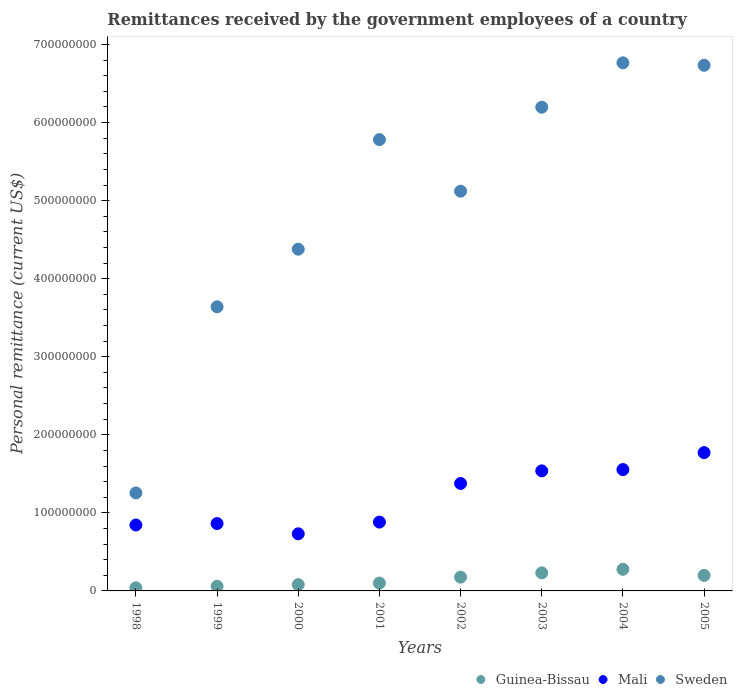What is the remittances received by the government employees in Sweden in 2004?
Offer a terse response. 6.77e+08. Across all years, what is the maximum remittances received by the government employees in Guinea-Bissau?
Your answer should be very brief. 2.77e+07. Across all years, what is the minimum remittances received by the government employees in Mali?
Keep it short and to the point. 7.32e+07. In which year was the remittances received by the government employees in Mali maximum?
Ensure brevity in your answer.  2005. What is the total remittances received by the government employees in Guinea-Bissau in the graph?
Your response must be concise. 1.16e+08. What is the difference between the remittances received by the government employees in Sweden in 1998 and that in 2005?
Your answer should be compact. -5.48e+08. What is the difference between the remittances received by the government employees in Guinea-Bissau in 2001 and the remittances received by the government employees in Mali in 2005?
Provide a short and direct response. -1.67e+08. What is the average remittances received by the government employees in Guinea-Bissau per year?
Make the answer very short. 1.46e+07. In the year 2002, what is the difference between the remittances received by the government employees in Mali and remittances received by the government employees in Sweden?
Provide a short and direct response. -3.74e+08. What is the ratio of the remittances received by the government employees in Mali in 2002 to that in 2003?
Provide a succinct answer. 0.9. Is the remittances received by the government employees in Mali in 1998 less than that in 2005?
Offer a terse response. Yes. Is the difference between the remittances received by the government employees in Mali in 1999 and 2002 greater than the difference between the remittances received by the government employees in Sweden in 1999 and 2002?
Offer a very short reply. Yes. What is the difference between the highest and the second highest remittances received by the government employees in Guinea-Bissau?
Offer a terse response. 4.57e+06. What is the difference between the highest and the lowest remittances received by the government employees in Guinea-Bissau?
Provide a short and direct response. 2.37e+07. In how many years, is the remittances received by the government employees in Sweden greater than the average remittances received by the government employees in Sweden taken over all years?
Your response must be concise. 5. Is it the case that in every year, the sum of the remittances received by the government employees in Mali and remittances received by the government employees in Guinea-Bissau  is greater than the remittances received by the government employees in Sweden?
Make the answer very short. No. Is the remittances received by the government employees in Sweden strictly less than the remittances received by the government employees in Guinea-Bissau over the years?
Give a very brief answer. No. What is the difference between two consecutive major ticks on the Y-axis?
Give a very brief answer. 1.00e+08. Are the values on the major ticks of Y-axis written in scientific E-notation?
Your answer should be very brief. No. Does the graph contain grids?
Your response must be concise. No. How many legend labels are there?
Your response must be concise. 3. How are the legend labels stacked?
Offer a terse response. Horizontal. What is the title of the graph?
Provide a short and direct response. Remittances received by the government employees of a country. What is the label or title of the X-axis?
Give a very brief answer. Years. What is the label or title of the Y-axis?
Provide a short and direct response. Personal remittance (current US$). What is the Personal remittance (current US$) in Guinea-Bissau in 1998?
Provide a succinct answer. 4.01e+06. What is the Personal remittance (current US$) of Mali in 1998?
Your response must be concise. 8.45e+07. What is the Personal remittance (current US$) of Sweden in 1998?
Your answer should be compact. 1.26e+08. What is the Personal remittance (current US$) of Guinea-Bissau in 1999?
Make the answer very short. 6.01e+06. What is the Personal remittance (current US$) in Mali in 1999?
Ensure brevity in your answer.  8.63e+07. What is the Personal remittance (current US$) in Sweden in 1999?
Provide a short and direct response. 3.64e+08. What is the Personal remittance (current US$) of Guinea-Bissau in 2000?
Your answer should be very brief. 8.02e+06. What is the Personal remittance (current US$) in Mali in 2000?
Give a very brief answer. 7.32e+07. What is the Personal remittance (current US$) in Sweden in 2000?
Your answer should be compact. 4.38e+08. What is the Personal remittance (current US$) in Guinea-Bissau in 2001?
Your answer should be compact. 1.00e+07. What is the Personal remittance (current US$) of Mali in 2001?
Keep it short and to the point. 8.82e+07. What is the Personal remittance (current US$) of Sweden in 2001?
Offer a very short reply. 5.78e+08. What is the Personal remittance (current US$) in Guinea-Bissau in 2002?
Offer a very short reply. 1.76e+07. What is the Personal remittance (current US$) in Mali in 2002?
Keep it short and to the point. 1.38e+08. What is the Personal remittance (current US$) in Sweden in 2002?
Ensure brevity in your answer.  5.12e+08. What is the Personal remittance (current US$) in Guinea-Bissau in 2003?
Your answer should be very brief. 2.31e+07. What is the Personal remittance (current US$) in Mali in 2003?
Ensure brevity in your answer.  1.54e+08. What is the Personal remittance (current US$) of Sweden in 2003?
Offer a very short reply. 6.20e+08. What is the Personal remittance (current US$) of Guinea-Bissau in 2004?
Ensure brevity in your answer.  2.77e+07. What is the Personal remittance (current US$) of Mali in 2004?
Make the answer very short. 1.55e+08. What is the Personal remittance (current US$) of Sweden in 2004?
Provide a succinct answer. 6.77e+08. What is the Personal remittance (current US$) in Guinea-Bissau in 2005?
Keep it short and to the point. 1.99e+07. What is the Personal remittance (current US$) in Mali in 2005?
Ensure brevity in your answer.  1.77e+08. What is the Personal remittance (current US$) in Sweden in 2005?
Keep it short and to the point. 6.73e+08. Across all years, what is the maximum Personal remittance (current US$) in Guinea-Bissau?
Ensure brevity in your answer.  2.77e+07. Across all years, what is the maximum Personal remittance (current US$) in Mali?
Make the answer very short. 1.77e+08. Across all years, what is the maximum Personal remittance (current US$) of Sweden?
Your answer should be compact. 6.77e+08. Across all years, what is the minimum Personal remittance (current US$) in Guinea-Bissau?
Your answer should be compact. 4.01e+06. Across all years, what is the minimum Personal remittance (current US$) of Mali?
Provide a short and direct response. 7.32e+07. Across all years, what is the minimum Personal remittance (current US$) of Sweden?
Your response must be concise. 1.26e+08. What is the total Personal remittance (current US$) of Guinea-Bissau in the graph?
Give a very brief answer. 1.16e+08. What is the total Personal remittance (current US$) of Mali in the graph?
Offer a terse response. 9.56e+08. What is the total Personal remittance (current US$) of Sweden in the graph?
Your response must be concise. 3.99e+09. What is the difference between the Personal remittance (current US$) in Guinea-Bissau in 1998 and that in 1999?
Ensure brevity in your answer.  -2.01e+06. What is the difference between the Personal remittance (current US$) of Mali in 1998 and that in 1999?
Ensure brevity in your answer.  -1.85e+06. What is the difference between the Personal remittance (current US$) of Sweden in 1998 and that in 1999?
Make the answer very short. -2.38e+08. What is the difference between the Personal remittance (current US$) in Guinea-Bissau in 1998 and that in 2000?
Your answer should be compact. -4.01e+06. What is the difference between the Personal remittance (current US$) of Mali in 1998 and that in 2000?
Offer a terse response. 1.13e+07. What is the difference between the Personal remittance (current US$) of Sweden in 1998 and that in 2000?
Make the answer very short. -3.12e+08. What is the difference between the Personal remittance (current US$) of Guinea-Bissau in 1998 and that in 2001?
Provide a short and direct response. -6.02e+06. What is the difference between the Personal remittance (current US$) in Mali in 1998 and that in 2001?
Your answer should be compact. -3.70e+06. What is the difference between the Personal remittance (current US$) in Sweden in 1998 and that in 2001?
Provide a short and direct response. -4.53e+08. What is the difference between the Personal remittance (current US$) in Guinea-Bissau in 1998 and that in 2002?
Give a very brief answer. -1.36e+07. What is the difference between the Personal remittance (current US$) of Mali in 1998 and that in 2002?
Make the answer very short. -5.32e+07. What is the difference between the Personal remittance (current US$) in Sweden in 1998 and that in 2002?
Offer a very short reply. -3.87e+08. What is the difference between the Personal remittance (current US$) of Guinea-Bissau in 1998 and that in 2003?
Provide a succinct answer. -1.91e+07. What is the difference between the Personal remittance (current US$) of Mali in 1998 and that in 2003?
Make the answer very short. -6.93e+07. What is the difference between the Personal remittance (current US$) in Sweden in 1998 and that in 2003?
Provide a succinct answer. -4.94e+08. What is the difference between the Personal remittance (current US$) of Guinea-Bissau in 1998 and that in 2004?
Make the answer very short. -2.37e+07. What is the difference between the Personal remittance (current US$) in Mali in 1998 and that in 2004?
Ensure brevity in your answer.  -7.10e+07. What is the difference between the Personal remittance (current US$) of Sweden in 1998 and that in 2004?
Offer a very short reply. -5.51e+08. What is the difference between the Personal remittance (current US$) of Guinea-Bissau in 1998 and that in 2005?
Offer a very short reply. -1.59e+07. What is the difference between the Personal remittance (current US$) of Mali in 1998 and that in 2005?
Your answer should be compact. -9.27e+07. What is the difference between the Personal remittance (current US$) in Sweden in 1998 and that in 2005?
Ensure brevity in your answer.  -5.48e+08. What is the difference between the Personal remittance (current US$) of Guinea-Bissau in 1999 and that in 2000?
Provide a succinct answer. -2.01e+06. What is the difference between the Personal remittance (current US$) of Mali in 1999 and that in 2000?
Your answer should be very brief. 1.31e+07. What is the difference between the Personal remittance (current US$) of Sweden in 1999 and that in 2000?
Make the answer very short. -7.38e+07. What is the difference between the Personal remittance (current US$) of Guinea-Bissau in 1999 and that in 2001?
Offer a terse response. -4.01e+06. What is the difference between the Personal remittance (current US$) of Mali in 1999 and that in 2001?
Offer a very short reply. -1.86e+06. What is the difference between the Personal remittance (current US$) in Sweden in 1999 and that in 2001?
Your answer should be very brief. -2.14e+08. What is the difference between the Personal remittance (current US$) in Guinea-Bissau in 1999 and that in 2002?
Ensure brevity in your answer.  -1.16e+07. What is the difference between the Personal remittance (current US$) of Mali in 1999 and that in 2002?
Provide a short and direct response. -5.13e+07. What is the difference between the Personal remittance (current US$) in Sweden in 1999 and that in 2002?
Ensure brevity in your answer.  -1.48e+08. What is the difference between the Personal remittance (current US$) in Guinea-Bissau in 1999 and that in 2003?
Offer a very short reply. -1.71e+07. What is the difference between the Personal remittance (current US$) of Mali in 1999 and that in 2003?
Make the answer very short. -6.75e+07. What is the difference between the Personal remittance (current US$) of Sweden in 1999 and that in 2003?
Ensure brevity in your answer.  -2.56e+08. What is the difference between the Personal remittance (current US$) of Guinea-Bissau in 1999 and that in 2004?
Make the answer very short. -2.17e+07. What is the difference between the Personal remittance (current US$) in Mali in 1999 and that in 2004?
Your response must be concise. -6.92e+07. What is the difference between the Personal remittance (current US$) of Sweden in 1999 and that in 2004?
Provide a succinct answer. -3.13e+08. What is the difference between the Personal remittance (current US$) in Guinea-Bissau in 1999 and that in 2005?
Your answer should be very brief. -1.39e+07. What is the difference between the Personal remittance (current US$) of Mali in 1999 and that in 2005?
Give a very brief answer. -9.09e+07. What is the difference between the Personal remittance (current US$) in Sweden in 1999 and that in 2005?
Your answer should be very brief. -3.09e+08. What is the difference between the Personal remittance (current US$) of Guinea-Bissau in 2000 and that in 2001?
Give a very brief answer. -2.01e+06. What is the difference between the Personal remittance (current US$) in Mali in 2000 and that in 2001?
Give a very brief answer. -1.50e+07. What is the difference between the Personal remittance (current US$) in Sweden in 2000 and that in 2001?
Your answer should be very brief. -1.40e+08. What is the difference between the Personal remittance (current US$) in Guinea-Bissau in 2000 and that in 2002?
Your answer should be very brief. -9.61e+06. What is the difference between the Personal remittance (current US$) of Mali in 2000 and that in 2002?
Your response must be concise. -6.45e+07. What is the difference between the Personal remittance (current US$) of Sweden in 2000 and that in 2002?
Keep it short and to the point. -7.43e+07. What is the difference between the Personal remittance (current US$) of Guinea-Bissau in 2000 and that in 2003?
Provide a short and direct response. -1.51e+07. What is the difference between the Personal remittance (current US$) of Mali in 2000 and that in 2003?
Provide a short and direct response. -8.06e+07. What is the difference between the Personal remittance (current US$) of Sweden in 2000 and that in 2003?
Your answer should be compact. -1.82e+08. What is the difference between the Personal remittance (current US$) of Guinea-Bissau in 2000 and that in 2004?
Offer a terse response. -1.97e+07. What is the difference between the Personal remittance (current US$) in Mali in 2000 and that in 2004?
Offer a terse response. -8.23e+07. What is the difference between the Personal remittance (current US$) in Sweden in 2000 and that in 2004?
Provide a short and direct response. -2.39e+08. What is the difference between the Personal remittance (current US$) of Guinea-Bissau in 2000 and that in 2005?
Ensure brevity in your answer.  -1.19e+07. What is the difference between the Personal remittance (current US$) in Mali in 2000 and that in 2005?
Provide a succinct answer. -1.04e+08. What is the difference between the Personal remittance (current US$) of Sweden in 2000 and that in 2005?
Keep it short and to the point. -2.36e+08. What is the difference between the Personal remittance (current US$) in Guinea-Bissau in 2001 and that in 2002?
Give a very brief answer. -7.60e+06. What is the difference between the Personal remittance (current US$) of Mali in 2001 and that in 2002?
Keep it short and to the point. -4.95e+07. What is the difference between the Personal remittance (current US$) in Sweden in 2001 and that in 2002?
Give a very brief answer. 6.61e+07. What is the difference between the Personal remittance (current US$) of Guinea-Bissau in 2001 and that in 2003?
Ensure brevity in your answer.  -1.31e+07. What is the difference between the Personal remittance (current US$) of Mali in 2001 and that in 2003?
Provide a short and direct response. -6.56e+07. What is the difference between the Personal remittance (current US$) in Sweden in 2001 and that in 2003?
Your response must be concise. -4.15e+07. What is the difference between the Personal remittance (current US$) in Guinea-Bissau in 2001 and that in 2004?
Provide a succinct answer. -1.77e+07. What is the difference between the Personal remittance (current US$) in Mali in 2001 and that in 2004?
Offer a very short reply. -6.73e+07. What is the difference between the Personal remittance (current US$) of Sweden in 2001 and that in 2004?
Your answer should be compact. -9.84e+07. What is the difference between the Personal remittance (current US$) in Guinea-Bissau in 2001 and that in 2005?
Your response must be concise. -9.87e+06. What is the difference between the Personal remittance (current US$) of Mali in 2001 and that in 2005?
Provide a succinct answer. -8.90e+07. What is the difference between the Personal remittance (current US$) of Sweden in 2001 and that in 2005?
Give a very brief answer. -9.52e+07. What is the difference between the Personal remittance (current US$) of Guinea-Bissau in 2002 and that in 2003?
Your answer should be compact. -5.49e+06. What is the difference between the Personal remittance (current US$) of Mali in 2002 and that in 2003?
Your answer should be compact. -1.61e+07. What is the difference between the Personal remittance (current US$) in Sweden in 2002 and that in 2003?
Keep it short and to the point. -1.08e+08. What is the difference between the Personal remittance (current US$) in Guinea-Bissau in 2002 and that in 2004?
Your answer should be very brief. -1.01e+07. What is the difference between the Personal remittance (current US$) of Mali in 2002 and that in 2004?
Offer a very short reply. -1.78e+07. What is the difference between the Personal remittance (current US$) in Sweden in 2002 and that in 2004?
Keep it short and to the point. -1.64e+08. What is the difference between the Personal remittance (current US$) in Guinea-Bissau in 2002 and that in 2005?
Your answer should be very brief. -2.27e+06. What is the difference between the Personal remittance (current US$) in Mali in 2002 and that in 2005?
Offer a very short reply. -3.95e+07. What is the difference between the Personal remittance (current US$) in Sweden in 2002 and that in 2005?
Offer a very short reply. -1.61e+08. What is the difference between the Personal remittance (current US$) in Guinea-Bissau in 2003 and that in 2004?
Your answer should be compact. -4.57e+06. What is the difference between the Personal remittance (current US$) in Mali in 2003 and that in 2004?
Provide a short and direct response. -1.66e+06. What is the difference between the Personal remittance (current US$) in Sweden in 2003 and that in 2004?
Make the answer very short. -5.69e+07. What is the difference between the Personal remittance (current US$) of Guinea-Bissau in 2003 and that in 2005?
Your answer should be very brief. 3.23e+06. What is the difference between the Personal remittance (current US$) in Mali in 2003 and that in 2005?
Offer a very short reply. -2.34e+07. What is the difference between the Personal remittance (current US$) in Sweden in 2003 and that in 2005?
Offer a very short reply. -5.37e+07. What is the difference between the Personal remittance (current US$) in Guinea-Bissau in 2004 and that in 2005?
Offer a very short reply. 7.80e+06. What is the difference between the Personal remittance (current US$) in Mali in 2004 and that in 2005?
Ensure brevity in your answer.  -2.17e+07. What is the difference between the Personal remittance (current US$) in Sweden in 2004 and that in 2005?
Make the answer very short. 3.16e+06. What is the difference between the Personal remittance (current US$) of Guinea-Bissau in 1998 and the Personal remittance (current US$) of Mali in 1999?
Make the answer very short. -8.23e+07. What is the difference between the Personal remittance (current US$) of Guinea-Bissau in 1998 and the Personal remittance (current US$) of Sweden in 1999?
Give a very brief answer. -3.60e+08. What is the difference between the Personal remittance (current US$) in Mali in 1998 and the Personal remittance (current US$) in Sweden in 1999?
Provide a succinct answer. -2.80e+08. What is the difference between the Personal remittance (current US$) of Guinea-Bissau in 1998 and the Personal remittance (current US$) of Mali in 2000?
Ensure brevity in your answer.  -6.92e+07. What is the difference between the Personal remittance (current US$) of Guinea-Bissau in 1998 and the Personal remittance (current US$) of Sweden in 2000?
Your answer should be compact. -4.34e+08. What is the difference between the Personal remittance (current US$) of Mali in 1998 and the Personal remittance (current US$) of Sweden in 2000?
Provide a succinct answer. -3.53e+08. What is the difference between the Personal remittance (current US$) in Guinea-Bissau in 1998 and the Personal remittance (current US$) in Mali in 2001?
Make the answer very short. -8.42e+07. What is the difference between the Personal remittance (current US$) in Guinea-Bissau in 1998 and the Personal remittance (current US$) in Sweden in 2001?
Keep it short and to the point. -5.74e+08. What is the difference between the Personal remittance (current US$) of Mali in 1998 and the Personal remittance (current US$) of Sweden in 2001?
Offer a very short reply. -4.94e+08. What is the difference between the Personal remittance (current US$) of Guinea-Bissau in 1998 and the Personal remittance (current US$) of Mali in 2002?
Make the answer very short. -1.34e+08. What is the difference between the Personal remittance (current US$) in Guinea-Bissau in 1998 and the Personal remittance (current US$) in Sweden in 2002?
Offer a terse response. -5.08e+08. What is the difference between the Personal remittance (current US$) in Mali in 1998 and the Personal remittance (current US$) in Sweden in 2002?
Keep it short and to the point. -4.28e+08. What is the difference between the Personal remittance (current US$) in Guinea-Bissau in 1998 and the Personal remittance (current US$) in Mali in 2003?
Ensure brevity in your answer.  -1.50e+08. What is the difference between the Personal remittance (current US$) of Guinea-Bissau in 1998 and the Personal remittance (current US$) of Sweden in 2003?
Ensure brevity in your answer.  -6.16e+08. What is the difference between the Personal remittance (current US$) of Mali in 1998 and the Personal remittance (current US$) of Sweden in 2003?
Make the answer very short. -5.35e+08. What is the difference between the Personal remittance (current US$) of Guinea-Bissau in 1998 and the Personal remittance (current US$) of Mali in 2004?
Give a very brief answer. -1.51e+08. What is the difference between the Personal remittance (current US$) of Guinea-Bissau in 1998 and the Personal remittance (current US$) of Sweden in 2004?
Keep it short and to the point. -6.73e+08. What is the difference between the Personal remittance (current US$) in Mali in 1998 and the Personal remittance (current US$) in Sweden in 2004?
Provide a short and direct response. -5.92e+08. What is the difference between the Personal remittance (current US$) of Guinea-Bissau in 1998 and the Personal remittance (current US$) of Mali in 2005?
Your response must be concise. -1.73e+08. What is the difference between the Personal remittance (current US$) of Guinea-Bissau in 1998 and the Personal remittance (current US$) of Sweden in 2005?
Your response must be concise. -6.69e+08. What is the difference between the Personal remittance (current US$) in Mali in 1998 and the Personal remittance (current US$) in Sweden in 2005?
Your answer should be compact. -5.89e+08. What is the difference between the Personal remittance (current US$) of Guinea-Bissau in 1999 and the Personal remittance (current US$) of Mali in 2000?
Make the answer very short. -6.71e+07. What is the difference between the Personal remittance (current US$) of Guinea-Bissau in 1999 and the Personal remittance (current US$) of Sweden in 2000?
Make the answer very short. -4.32e+08. What is the difference between the Personal remittance (current US$) of Mali in 1999 and the Personal remittance (current US$) of Sweden in 2000?
Provide a succinct answer. -3.51e+08. What is the difference between the Personal remittance (current US$) in Guinea-Bissau in 1999 and the Personal remittance (current US$) in Mali in 2001?
Offer a terse response. -8.22e+07. What is the difference between the Personal remittance (current US$) of Guinea-Bissau in 1999 and the Personal remittance (current US$) of Sweden in 2001?
Keep it short and to the point. -5.72e+08. What is the difference between the Personal remittance (current US$) in Mali in 1999 and the Personal remittance (current US$) in Sweden in 2001?
Provide a short and direct response. -4.92e+08. What is the difference between the Personal remittance (current US$) of Guinea-Bissau in 1999 and the Personal remittance (current US$) of Mali in 2002?
Make the answer very short. -1.32e+08. What is the difference between the Personal remittance (current US$) of Guinea-Bissau in 1999 and the Personal remittance (current US$) of Sweden in 2002?
Make the answer very short. -5.06e+08. What is the difference between the Personal remittance (current US$) of Mali in 1999 and the Personal remittance (current US$) of Sweden in 2002?
Keep it short and to the point. -4.26e+08. What is the difference between the Personal remittance (current US$) of Guinea-Bissau in 1999 and the Personal remittance (current US$) of Mali in 2003?
Offer a terse response. -1.48e+08. What is the difference between the Personal remittance (current US$) of Guinea-Bissau in 1999 and the Personal remittance (current US$) of Sweden in 2003?
Give a very brief answer. -6.14e+08. What is the difference between the Personal remittance (current US$) in Mali in 1999 and the Personal remittance (current US$) in Sweden in 2003?
Make the answer very short. -5.33e+08. What is the difference between the Personal remittance (current US$) of Guinea-Bissau in 1999 and the Personal remittance (current US$) of Mali in 2004?
Keep it short and to the point. -1.49e+08. What is the difference between the Personal remittance (current US$) of Guinea-Bissau in 1999 and the Personal remittance (current US$) of Sweden in 2004?
Make the answer very short. -6.71e+08. What is the difference between the Personal remittance (current US$) of Mali in 1999 and the Personal remittance (current US$) of Sweden in 2004?
Offer a terse response. -5.90e+08. What is the difference between the Personal remittance (current US$) in Guinea-Bissau in 1999 and the Personal remittance (current US$) in Mali in 2005?
Provide a short and direct response. -1.71e+08. What is the difference between the Personal remittance (current US$) of Guinea-Bissau in 1999 and the Personal remittance (current US$) of Sweden in 2005?
Keep it short and to the point. -6.67e+08. What is the difference between the Personal remittance (current US$) of Mali in 1999 and the Personal remittance (current US$) of Sweden in 2005?
Keep it short and to the point. -5.87e+08. What is the difference between the Personal remittance (current US$) in Guinea-Bissau in 2000 and the Personal remittance (current US$) in Mali in 2001?
Offer a terse response. -8.01e+07. What is the difference between the Personal remittance (current US$) of Guinea-Bissau in 2000 and the Personal remittance (current US$) of Sweden in 2001?
Offer a very short reply. -5.70e+08. What is the difference between the Personal remittance (current US$) of Mali in 2000 and the Personal remittance (current US$) of Sweden in 2001?
Ensure brevity in your answer.  -5.05e+08. What is the difference between the Personal remittance (current US$) in Guinea-Bissau in 2000 and the Personal remittance (current US$) in Mali in 2002?
Your response must be concise. -1.30e+08. What is the difference between the Personal remittance (current US$) in Guinea-Bissau in 2000 and the Personal remittance (current US$) in Sweden in 2002?
Your response must be concise. -5.04e+08. What is the difference between the Personal remittance (current US$) of Mali in 2000 and the Personal remittance (current US$) of Sweden in 2002?
Offer a terse response. -4.39e+08. What is the difference between the Personal remittance (current US$) of Guinea-Bissau in 2000 and the Personal remittance (current US$) of Mali in 2003?
Ensure brevity in your answer.  -1.46e+08. What is the difference between the Personal remittance (current US$) of Guinea-Bissau in 2000 and the Personal remittance (current US$) of Sweden in 2003?
Offer a very short reply. -6.12e+08. What is the difference between the Personal remittance (current US$) in Mali in 2000 and the Personal remittance (current US$) in Sweden in 2003?
Make the answer very short. -5.47e+08. What is the difference between the Personal remittance (current US$) in Guinea-Bissau in 2000 and the Personal remittance (current US$) in Mali in 2004?
Ensure brevity in your answer.  -1.47e+08. What is the difference between the Personal remittance (current US$) of Guinea-Bissau in 2000 and the Personal remittance (current US$) of Sweden in 2004?
Provide a short and direct response. -6.69e+08. What is the difference between the Personal remittance (current US$) in Mali in 2000 and the Personal remittance (current US$) in Sweden in 2004?
Give a very brief answer. -6.03e+08. What is the difference between the Personal remittance (current US$) in Guinea-Bissau in 2000 and the Personal remittance (current US$) in Mali in 2005?
Keep it short and to the point. -1.69e+08. What is the difference between the Personal remittance (current US$) in Guinea-Bissau in 2000 and the Personal remittance (current US$) in Sweden in 2005?
Keep it short and to the point. -6.65e+08. What is the difference between the Personal remittance (current US$) in Mali in 2000 and the Personal remittance (current US$) in Sweden in 2005?
Your response must be concise. -6.00e+08. What is the difference between the Personal remittance (current US$) in Guinea-Bissau in 2001 and the Personal remittance (current US$) in Mali in 2002?
Give a very brief answer. -1.28e+08. What is the difference between the Personal remittance (current US$) of Guinea-Bissau in 2001 and the Personal remittance (current US$) of Sweden in 2002?
Offer a terse response. -5.02e+08. What is the difference between the Personal remittance (current US$) in Mali in 2001 and the Personal remittance (current US$) in Sweden in 2002?
Give a very brief answer. -4.24e+08. What is the difference between the Personal remittance (current US$) in Guinea-Bissau in 2001 and the Personal remittance (current US$) in Mali in 2003?
Provide a short and direct response. -1.44e+08. What is the difference between the Personal remittance (current US$) of Guinea-Bissau in 2001 and the Personal remittance (current US$) of Sweden in 2003?
Keep it short and to the point. -6.10e+08. What is the difference between the Personal remittance (current US$) in Mali in 2001 and the Personal remittance (current US$) in Sweden in 2003?
Make the answer very short. -5.32e+08. What is the difference between the Personal remittance (current US$) of Guinea-Bissau in 2001 and the Personal remittance (current US$) of Mali in 2004?
Ensure brevity in your answer.  -1.45e+08. What is the difference between the Personal remittance (current US$) of Guinea-Bissau in 2001 and the Personal remittance (current US$) of Sweden in 2004?
Provide a short and direct response. -6.67e+08. What is the difference between the Personal remittance (current US$) in Mali in 2001 and the Personal remittance (current US$) in Sweden in 2004?
Provide a succinct answer. -5.88e+08. What is the difference between the Personal remittance (current US$) of Guinea-Bissau in 2001 and the Personal remittance (current US$) of Mali in 2005?
Keep it short and to the point. -1.67e+08. What is the difference between the Personal remittance (current US$) of Guinea-Bissau in 2001 and the Personal remittance (current US$) of Sweden in 2005?
Your answer should be compact. -6.63e+08. What is the difference between the Personal remittance (current US$) of Mali in 2001 and the Personal remittance (current US$) of Sweden in 2005?
Your answer should be very brief. -5.85e+08. What is the difference between the Personal remittance (current US$) in Guinea-Bissau in 2002 and the Personal remittance (current US$) in Mali in 2003?
Offer a terse response. -1.36e+08. What is the difference between the Personal remittance (current US$) of Guinea-Bissau in 2002 and the Personal remittance (current US$) of Sweden in 2003?
Your answer should be very brief. -6.02e+08. What is the difference between the Personal remittance (current US$) in Mali in 2002 and the Personal remittance (current US$) in Sweden in 2003?
Offer a terse response. -4.82e+08. What is the difference between the Personal remittance (current US$) of Guinea-Bissau in 2002 and the Personal remittance (current US$) of Mali in 2004?
Offer a very short reply. -1.38e+08. What is the difference between the Personal remittance (current US$) in Guinea-Bissau in 2002 and the Personal remittance (current US$) in Sweden in 2004?
Offer a very short reply. -6.59e+08. What is the difference between the Personal remittance (current US$) of Mali in 2002 and the Personal remittance (current US$) of Sweden in 2004?
Your answer should be very brief. -5.39e+08. What is the difference between the Personal remittance (current US$) of Guinea-Bissau in 2002 and the Personal remittance (current US$) of Mali in 2005?
Give a very brief answer. -1.60e+08. What is the difference between the Personal remittance (current US$) in Guinea-Bissau in 2002 and the Personal remittance (current US$) in Sweden in 2005?
Give a very brief answer. -6.56e+08. What is the difference between the Personal remittance (current US$) of Mali in 2002 and the Personal remittance (current US$) of Sweden in 2005?
Give a very brief answer. -5.36e+08. What is the difference between the Personal remittance (current US$) in Guinea-Bissau in 2003 and the Personal remittance (current US$) in Mali in 2004?
Your response must be concise. -1.32e+08. What is the difference between the Personal remittance (current US$) of Guinea-Bissau in 2003 and the Personal remittance (current US$) of Sweden in 2004?
Make the answer very short. -6.53e+08. What is the difference between the Personal remittance (current US$) of Mali in 2003 and the Personal remittance (current US$) of Sweden in 2004?
Provide a short and direct response. -5.23e+08. What is the difference between the Personal remittance (current US$) of Guinea-Bissau in 2003 and the Personal remittance (current US$) of Mali in 2005?
Provide a succinct answer. -1.54e+08. What is the difference between the Personal remittance (current US$) of Guinea-Bissau in 2003 and the Personal remittance (current US$) of Sweden in 2005?
Give a very brief answer. -6.50e+08. What is the difference between the Personal remittance (current US$) in Mali in 2003 and the Personal remittance (current US$) in Sweden in 2005?
Ensure brevity in your answer.  -5.20e+08. What is the difference between the Personal remittance (current US$) of Guinea-Bissau in 2004 and the Personal remittance (current US$) of Mali in 2005?
Provide a short and direct response. -1.49e+08. What is the difference between the Personal remittance (current US$) of Guinea-Bissau in 2004 and the Personal remittance (current US$) of Sweden in 2005?
Provide a succinct answer. -6.46e+08. What is the difference between the Personal remittance (current US$) in Mali in 2004 and the Personal remittance (current US$) in Sweden in 2005?
Provide a short and direct response. -5.18e+08. What is the average Personal remittance (current US$) in Guinea-Bissau per year?
Offer a terse response. 1.46e+07. What is the average Personal remittance (current US$) of Mali per year?
Offer a very short reply. 1.20e+08. What is the average Personal remittance (current US$) of Sweden per year?
Keep it short and to the point. 4.98e+08. In the year 1998, what is the difference between the Personal remittance (current US$) of Guinea-Bissau and Personal remittance (current US$) of Mali?
Provide a succinct answer. -8.05e+07. In the year 1998, what is the difference between the Personal remittance (current US$) in Guinea-Bissau and Personal remittance (current US$) in Sweden?
Your answer should be compact. -1.22e+08. In the year 1998, what is the difference between the Personal remittance (current US$) in Mali and Personal remittance (current US$) in Sweden?
Offer a terse response. -4.11e+07. In the year 1999, what is the difference between the Personal remittance (current US$) in Guinea-Bissau and Personal remittance (current US$) in Mali?
Your response must be concise. -8.03e+07. In the year 1999, what is the difference between the Personal remittance (current US$) of Guinea-Bissau and Personal remittance (current US$) of Sweden?
Offer a very short reply. -3.58e+08. In the year 1999, what is the difference between the Personal remittance (current US$) of Mali and Personal remittance (current US$) of Sweden?
Your answer should be very brief. -2.78e+08. In the year 2000, what is the difference between the Personal remittance (current US$) of Guinea-Bissau and Personal remittance (current US$) of Mali?
Your response must be concise. -6.51e+07. In the year 2000, what is the difference between the Personal remittance (current US$) of Guinea-Bissau and Personal remittance (current US$) of Sweden?
Provide a succinct answer. -4.30e+08. In the year 2000, what is the difference between the Personal remittance (current US$) in Mali and Personal remittance (current US$) in Sweden?
Provide a succinct answer. -3.65e+08. In the year 2001, what is the difference between the Personal remittance (current US$) in Guinea-Bissau and Personal remittance (current US$) in Mali?
Make the answer very short. -7.81e+07. In the year 2001, what is the difference between the Personal remittance (current US$) in Guinea-Bissau and Personal remittance (current US$) in Sweden?
Ensure brevity in your answer.  -5.68e+08. In the year 2001, what is the difference between the Personal remittance (current US$) of Mali and Personal remittance (current US$) of Sweden?
Keep it short and to the point. -4.90e+08. In the year 2002, what is the difference between the Personal remittance (current US$) of Guinea-Bissau and Personal remittance (current US$) of Mali?
Your response must be concise. -1.20e+08. In the year 2002, what is the difference between the Personal remittance (current US$) of Guinea-Bissau and Personal remittance (current US$) of Sweden?
Give a very brief answer. -4.94e+08. In the year 2002, what is the difference between the Personal remittance (current US$) in Mali and Personal remittance (current US$) in Sweden?
Keep it short and to the point. -3.74e+08. In the year 2003, what is the difference between the Personal remittance (current US$) of Guinea-Bissau and Personal remittance (current US$) of Mali?
Give a very brief answer. -1.31e+08. In the year 2003, what is the difference between the Personal remittance (current US$) in Guinea-Bissau and Personal remittance (current US$) in Sweden?
Your response must be concise. -5.97e+08. In the year 2003, what is the difference between the Personal remittance (current US$) in Mali and Personal remittance (current US$) in Sweden?
Your answer should be very brief. -4.66e+08. In the year 2004, what is the difference between the Personal remittance (current US$) in Guinea-Bissau and Personal remittance (current US$) in Mali?
Keep it short and to the point. -1.28e+08. In the year 2004, what is the difference between the Personal remittance (current US$) in Guinea-Bissau and Personal remittance (current US$) in Sweden?
Your answer should be compact. -6.49e+08. In the year 2004, what is the difference between the Personal remittance (current US$) of Mali and Personal remittance (current US$) of Sweden?
Your answer should be compact. -5.21e+08. In the year 2005, what is the difference between the Personal remittance (current US$) of Guinea-Bissau and Personal remittance (current US$) of Mali?
Give a very brief answer. -1.57e+08. In the year 2005, what is the difference between the Personal remittance (current US$) in Guinea-Bissau and Personal remittance (current US$) in Sweden?
Give a very brief answer. -6.54e+08. In the year 2005, what is the difference between the Personal remittance (current US$) of Mali and Personal remittance (current US$) of Sweden?
Offer a terse response. -4.96e+08. What is the ratio of the Personal remittance (current US$) in Guinea-Bissau in 1998 to that in 1999?
Offer a very short reply. 0.67. What is the ratio of the Personal remittance (current US$) of Mali in 1998 to that in 1999?
Your answer should be very brief. 0.98. What is the ratio of the Personal remittance (current US$) of Sweden in 1998 to that in 1999?
Your response must be concise. 0.34. What is the ratio of the Personal remittance (current US$) of Guinea-Bissau in 1998 to that in 2000?
Provide a succinct answer. 0.5. What is the ratio of the Personal remittance (current US$) in Mali in 1998 to that in 2000?
Your answer should be very brief. 1.15. What is the ratio of the Personal remittance (current US$) in Sweden in 1998 to that in 2000?
Make the answer very short. 0.29. What is the ratio of the Personal remittance (current US$) in Guinea-Bissau in 1998 to that in 2001?
Your response must be concise. 0.4. What is the ratio of the Personal remittance (current US$) of Mali in 1998 to that in 2001?
Your answer should be compact. 0.96. What is the ratio of the Personal remittance (current US$) in Sweden in 1998 to that in 2001?
Keep it short and to the point. 0.22. What is the ratio of the Personal remittance (current US$) of Guinea-Bissau in 1998 to that in 2002?
Your answer should be compact. 0.23. What is the ratio of the Personal remittance (current US$) of Mali in 1998 to that in 2002?
Offer a terse response. 0.61. What is the ratio of the Personal remittance (current US$) of Sweden in 1998 to that in 2002?
Offer a terse response. 0.25. What is the ratio of the Personal remittance (current US$) of Guinea-Bissau in 1998 to that in 2003?
Provide a short and direct response. 0.17. What is the ratio of the Personal remittance (current US$) in Mali in 1998 to that in 2003?
Keep it short and to the point. 0.55. What is the ratio of the Personal remittance (current US$) in Sweden in 1998 to that in 2003?
Provide a short and direct response. 0.2. What is the ratio of the Personal remittance (current US$) in Guinea-Bissau in 1998 to that in 2004?
Keep it short and to the point. 0.14. What is the ratio of the Personal remittance (current US$) of Mali in 1998 to that in 2004?
Give a very brief answer. 0.54. What is the ratio of the Personal remittance (current US$) in Sweden in 1998 to that in 2004?
Make the answer very short. 0.19. What is the ratio of the Personal remittance (current US$) of Guinea-Bissau in 1998 to that in 2005?
Your answer should be compact. 0.2. What is the ratio of the Personal remittance (current US$) in Mali in 1998 to that in 2005?
Provide a succinct answer. 0.48. What is the ratio of the Personal remittance (current US$) in Sweden in 1998 to that in 2005?
Keep it short and to the point. 0.19. What is the ratio of the Personal remittance (current US$) in Guinea-Bissau in 1999 to that in 2000?
Provide a succinct answer. 0.75. What is the ratio of the Personal remittance (current US$) in Mali in 1999 to that in 2000?
Your answer should be very brief. 1.18. What is the ratio of the Personal remittance (current US$) of Sweden in 1999 to that in 2000?
Provide a succinct answer. 0.83. What is the ratio of the Personal remittance (current US$) of Guinea-Bissau in 1999 to that in 2001?
Make the answer very short. 0.6. What is the ratio of the Personal remittance (current US$) of Mali in 1999 to that in 2001?
Give a very brief answer. 0.98. What is the ratio of the Personal remittance (current US$) in Sweden in 1999 to that in 2001?
Provide a succinct answer. 0.63. What is the ratio of the Personal remittance (current US$) of Guinea-Bissau in 1999 to that in 2002?
Give a very brief answer. 0.34. What is the ratio of the Personal remittance (current US$) of Mali in 1999 to that in 2002?
Your response must be concise. 0.63. What is the ratio of the Personal remittance (current US$) of Sweden in 1999 to that in 2002?
Make the answer very short. 0.71. What is the ratio of the Personal remittance (current US$) in Guinea-Bissau in 1999 to that in 2003?
Your response must be concise. 0.26. What is the ratio of the Personal remittance (current US$) in Mali in 1999 to that in 2003?
Your response must be concise. 0.56. What is the ratio of the Personal remittance (current US$) of Sweden in 1999 to that in 2003?
Provide a short and direct response. 0.59. What is the ratio of the Personal remittance (current US$) in Guinea-Bissau in 1999 to that in 2004?
Your answer should be very brief. 0.22. What is the ratio of the Personal remittance (current US$) of Mali in 1999 to that in 2004?
Provide a succinct answer. 0.56. What is the ratio of the Personal remittance (current US$) of Sweden in 1999 to that in 2004?
Your answer should be very brief. 0.54. What is the ratio of the Personal remittance (current US$) in Guinea-Bissau in 1999 to that in 2005?
Provide a short and direct response. 0.3. What is the ratio of the Personal remittance (current US$) in Mali in 1999 to that in 2005?
Provide a short and direct response. 0.49. What is the ratio of the Personal remittance (current US$) of Sweden in 1999 to that in 2005?
Provide a short and direct response. 0.54. What is the ratio of the Personal remittance (current US$) in Guinea-Bissau in 2000 to that in 2001?
Your answer should be very brief. 0.8. What is the ratio of the Personal remittance (current US$) of Mali in 2000 to that in 2001?
Provide a short and direct response. 0.83. What is the ratio of the Personal remittance (current US$) of Sweden in 2000 to that in 2001?
Your answer should be compact. 0.76. What is the ratio of the Personal remittance (current US$) of Guinea-Bissau in 2000 to that in 2002?
Your response must be concise. 0.45. What is the ratio of the Personal remittance (current US$) in Mali in 2000 to that in 2002?
Provide a succinct answer. 0.53. What is the ratio of the Personal remittance (current US$) in Sweden in 2000 to that in 2002?
Provide a short and direct response. 0.85. What is the ratio of the Personal remittance (current US$) in Guinea-Bissau in 2000 to that in 2003?
Keep it short and to the point. 0.35. What is the ratio of the Personal remittance (current US$) in Mali in 2000 to that in 2003?
Your response must be concise. 0.48. What is the ratio of the Personal remittance (current US$) in Sweden in 2000 to that in 2003?
Your response must be concise. 0.71. What is the ratio of the Personal remittance (current US$) of Guinea-Bissau in 2000 to that in 2004?
Offer a terse response. 0.29. What is the ratio of the Personal remittance (current US$) of Mali in 2000 to that in 2004?
Your answer should be very brief. 0.47. What is the ratio of the Personal remittance (current US$) of Sweden in 2000 to that in 2004?
Your answer should be very brief. 0.65. What is the ratio of the Personal remittance (current US$) of Guinea-Bissau in 2000 to that in 2005?
Provide a succinct answer. 0.4. What is the ratio of the Personal remittance (current US$) of Mali in 2000 to that in 2005?
Your response must be concise. 0.41. What is the ratio of the Personal remittance (current US$) of Sweden in 2000 to that in 2005?
Offer a very short reply. 0.65. What is the ratio of the Personal remittance (current US$) in Guinea-Bissau in 2001 to that in 2002?
Offer a very short reply. 0.57. What is the ratio of the Personal remittance (current US$) in Mali in 2001 to that in 2002?
Make the answer very short. 0.64. What is the ratio of the Personal remittance (current US$) of Sweden in 2001 to that in 2002?
Keep it short and to the point. 1.13. What is the ratio of the Personal remittance (current US$) of Guinea-Bissau in 2001 to that in 2003?
Your response must be concise. 0.43. What is the ratio of the Personal remittance (current US$) of Mali in 2001 to that in 2003?
Make the answer very short. 0.57. What is the ratio of the Personal remittance (current US$) in Sweden in 2001 to that in 2003?
Offer a very short reply. 0.93. What is the ratio of the Personal remittance (current US$) in Guinea-Bissau in 2001 to that in 2004?
Give a very brief answer. 0.36. What is the ratio of the Personal remittance (current US$) in Mali in 2001 to that in 2004?
Your answer should be very brief. 0.57. What is the ratio of the Personal remittance (current US$) of Sweden in 2001 to that in 2004?
Offer a terse response. 0.85. What is the ratio of the Personal remittance (current US$) in Guinea-Bissau in 2001 to that in 2005?
Ensure brevity in your answer.  0.5. What is the ratio of the Personal remittance (current US$) of Mali in 2001 to that in 2005?
Give a very brief answer. 0.5. What is the ratio of the Personal remittance (current US$) in Sweden in 2001 to that in 2005?
Keep it short and to the point. 0.86. What is the ratio of the Personal remittance (current US$) of Guinea-Bissau in 2002 to that in 2003?
Offer a very short reply. 0.76. What is the ratio of the Personal remittance (current US$) of Mali in 2002 to that in 2003?
Keep it short and to the point. 0.9. What is the ratio of the Personal remittance (current US$) of Sweden in 2002 to that in 2003?
Give a very brief answer. 0.83. What is the ratio of the Personal remittance (current US$) in Guinea-Bissau in 2002 to that in 2004?
Make the answer very short. 0.64. What is the ratio of the Personal remittance (current US$) of Mali in 2002 to that in 2004?
Give a very brief answer. 0.89. What is the ratio of the Personal remittance (current US$) of Sweden in 2002 to that in 2004?
Make the answer very short. 0.76. What is the ratio of the Personal remittance (current US$) in Guinea-Bissau in 2002 to that in 2005?
Your answer should be very brief. 0.89. What is the ratio of the Personal remittance (current US$) of Mali in 2002 to that in 2005?
Offer a terse response. 0.78. What is the ratio of the Personal remittance (current US$) in Sweden in 2002 to that in 2005?
Give a very brief answer. 0.76. What is the ratio of the Personal remittance (current US$) in Guinea-Bissau in 2003 to that in 2004?
Offer a very short reply. 0.83. What is the ratio of the Personal remittance (current US$) in Mali in 2003 to that in 2004?
Offer a terse response. 0.99. What is the ratio of the Personal remittance (current US$) in Sweden in 2003 to that in 2004?
Make the answer very short. 0.92. What is the ratio of the Personal remittance (current US$) in Guinea-Bissau in 2003 to that in 2005?
Provide a succinct answer. 1.16. What is the ratio of the Personal remittance (current US$) of Mali in 2003 to that in 2005?
Your answer should be very brief. 0.87. What is the ratio of the Personal remittance (current US$) of Sweden in 2003 to that in 2005?
Give a very brief answer. 0.92. What is the ratio of the Personal remittance (current US$) of Guinea-Bissau in 2004 to that in 2005?
Keep it short and to the point. 1.39. What is the ratio of the Personal remittance (current US$) of Mali in 2004 to that in 2005?
Keep it short and to the point. 0.88. What is the ratio of the Personal remittance (current US$) in Sweden in 2004 to that in 2005?
Provide a succinct answer. 1. What is the difference between the highest and the second highest Personal remittance (current US$) in Guinea-Bissau?
Provide a succinct answer. 4.57e+06. What is the difference between the highest and the second highest Personal remittance (current US$) in Mali?
Give a very brief answer. 2.17e+07. What is the difference between the highest and the second highest Personal remittance (current US$) of Sweden?
Your answer should be very brief. 3.16e+06. What is the difference between the highest and the lowest Personal remittance (current US$) of Guinea-Bissau?
Make the answer very short. 2.37e+07. What is the difference between the highest and the lowest Personal remittance (current US$) in Mali?
Your answer should be very brief. 1.04e+08. What is the difference between the highest and the lowest Personal remittance (current US$) of Sweden?
Give a very brief answer. 5.51e+08. 